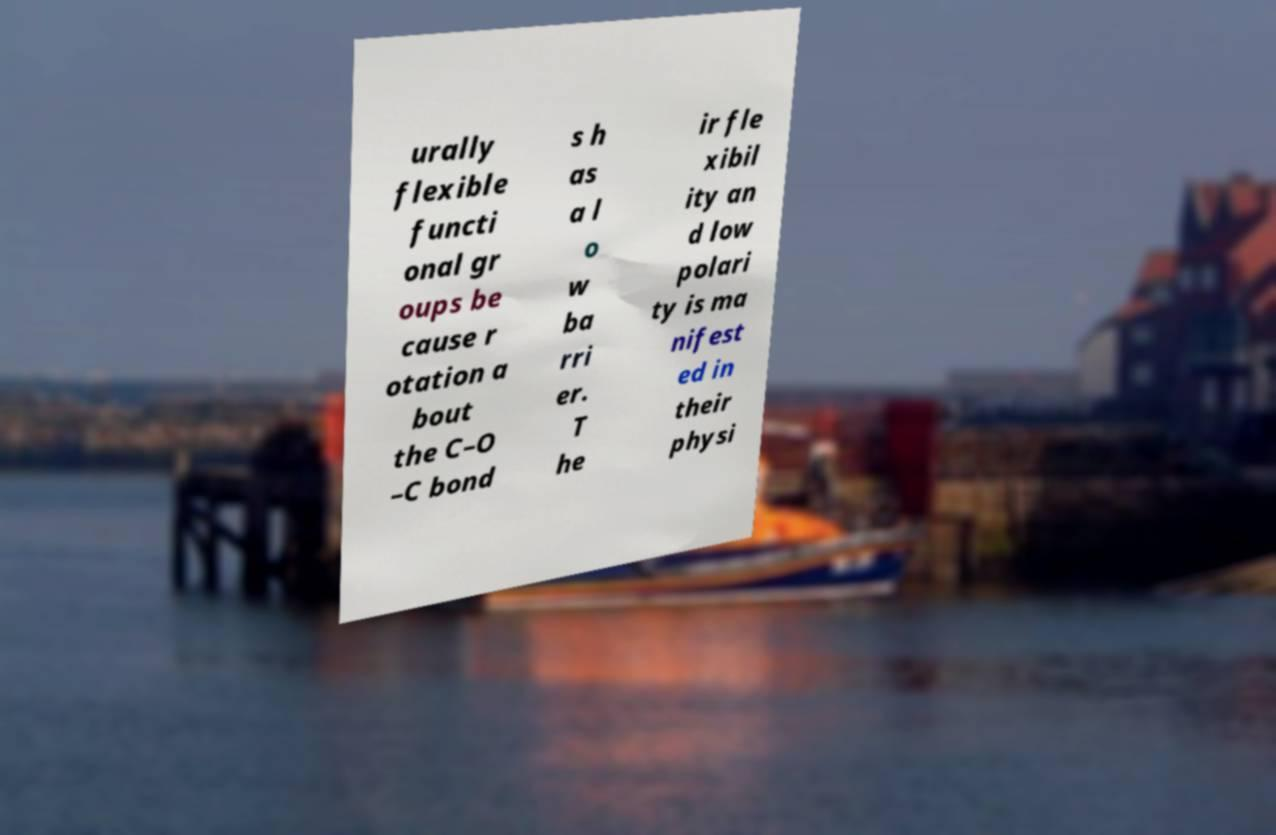Please read and relay the text visible in this image. What does it say? urally flexible functi onal gr oups be cause r otation a bout the C–O –C bond s h as a l o w ba rri er. T he ir fle xibil ity an d low polari ty is ma nifest ed in their physi 